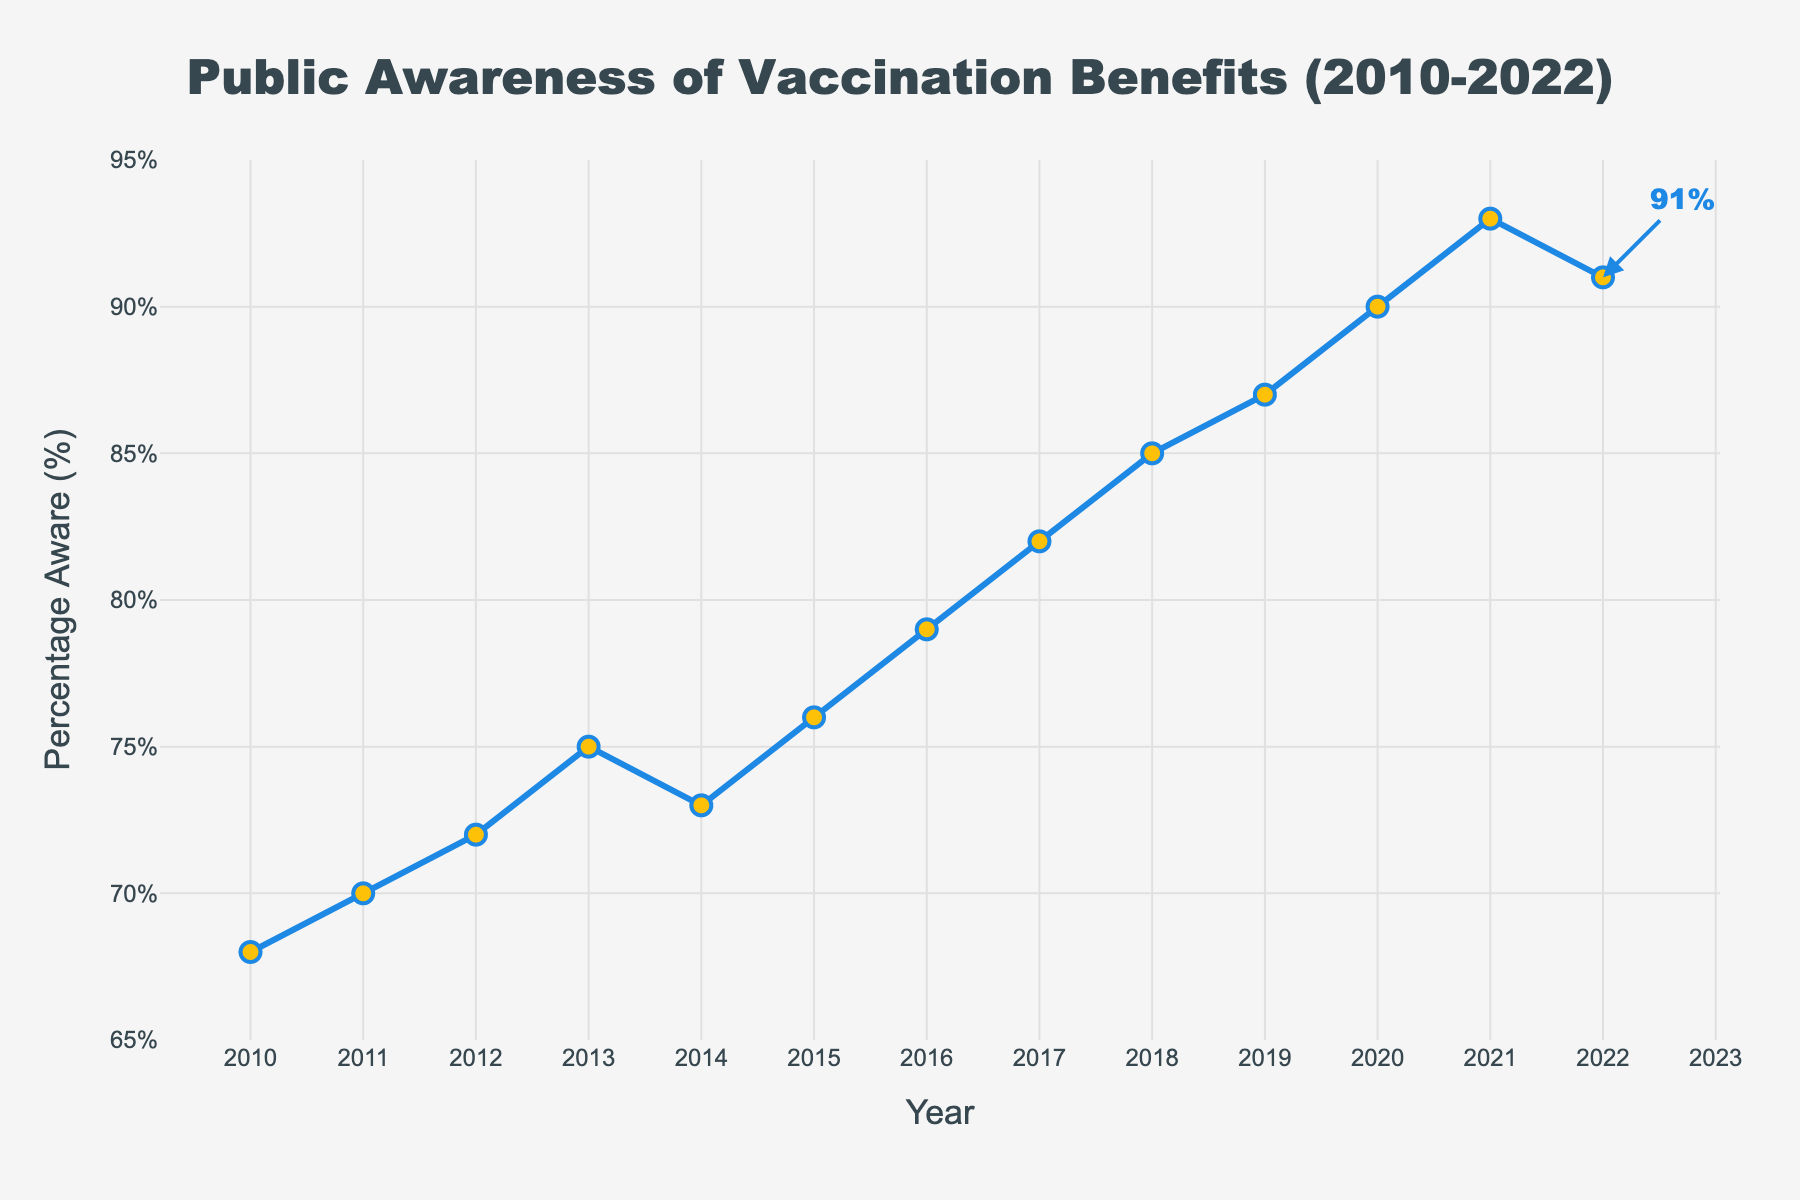What year showed the highest percentage of public awareness? The highest percentage of public awareness can be identified by looking for the peak value on the y-axis. The highest point on the line is at 93% in 2021.
Answer: 2021 Which year had a higher percentage of public awareness, 2014 or 2015? Compare the y-axis values for the years 2014 and 2015. The awareness percentage in 2014 is 73%, while in 2015, it is 76%.
Answer: 2015 By how many percentage points did public awareness increase from 2010 to 2021? Subtract the percentage of awareness in 2010 from that in 2021. This is 93% - 68% = 25%.
Answer: 25% What is the average percentage of public awareness from 2016 to 2020? Sum the awareness percentages from 2016 to 2020 and divide by the number of years: (79% + 82% + 85% + 87% + 90%) / 5 = 84.6%.
Answer: 84.6% What was the overall trend in public awareness from 2010 to 2022? Observe the overall direction of the line from 2010 to 2022. The line trend is upward, indicating an increase in public awareness over the years.
Answer: Increasing What was the percentage decrease in public awareness from 2021 to 2022? Subtract the 2022 percentage from the 2021 percentage and note the decrease: 93% - 91% = 2%.
Answer: 2% Between which years did the largest year-on-year increase in public awareness occur? Calculate the difference in awareness percentage between each consecutive year and identify the largest: The largest increase is from 2016 to 2017 with an increase of 82% - 79% = 3%.
Answer: 2016-2017 How many years showed a percentage of public awareness of more than 80%? Count the number of years where the percentage is above 80%. The years are 2017, 2018, 2019, 2020, 2021, and 2022, making a total of 6 years.
Answer: 6 What is the percentage change in public awareness between the first and last years on the chart? Calculate the percentage change as follows: ((91 - 68)/68) * 100 = 33.82%.
Answer: 33.82% 